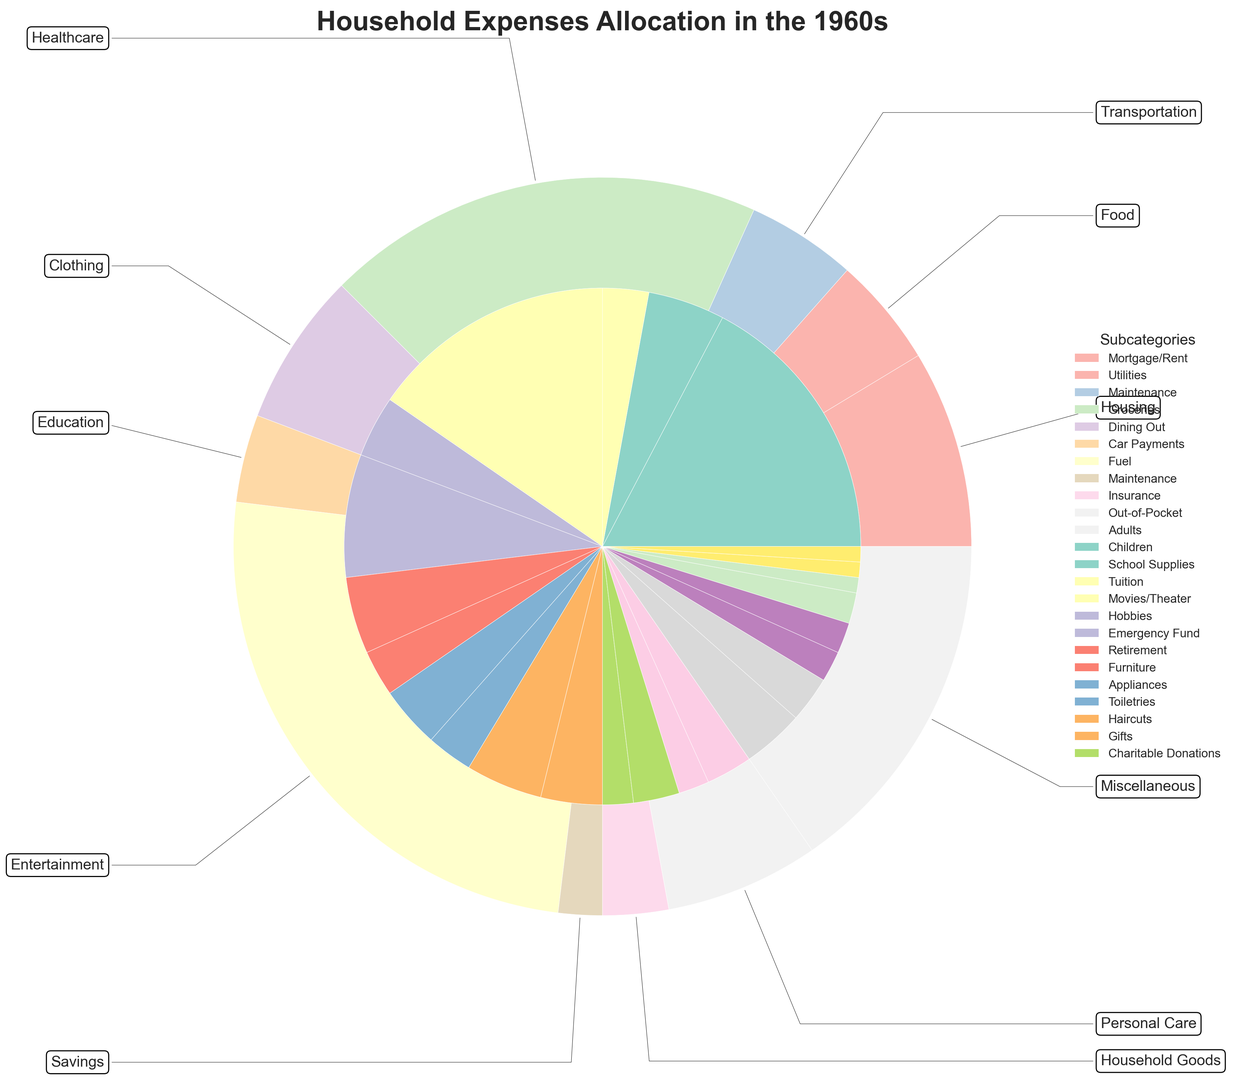What is the category with the highest proportion of expenses? According to the chart, Housing appears to have the largest segment, indicated by its significant portion of the outer pie chart as compared to other categories.
Answer: Housing How much more is spent on Housing compared to Transportation? Housing has 26% of the total expenses (18% Mortgage/Rent, 5% Utilities, 3% Maintenance), and Transportation has 16% of the total expenses (8% Car Payments, 5% Fuel, 3% Maintenance). The difference is 26% - 16% = 10%.
Answer: 10% Which subcategory has the highest percentage within the Food category? Within the Food category, the subcategories are Groceries (16%) and Dining Out (4%). Groceries has the higher percentage.
Answer: Groceries How does the percentage spent on Healthcare compare to the percentage spent on Entertainment? Healthcare stands at 7% (4% Insurance, 3% Out-of-Pocket) whereas Entertainment stands at 5% (2% Movies/Theater, 3% Hobbies). Healthcare spending is higher by 2%.
Answer: Healthcare is higher by 2% What is the combined percentage of expenses on Personal Care and Miscellaneous? Personal Care comprises 3% (2% Toiletries, 1% Haircuts) and Miscellaneous also totals 2% (1% Gifts, 1% Charitable Donations). Combined, it's 3% + 2% = 5%.
Answer: 5% Which category has a smaller percentage of expenses, Clothing or Savings? Clothing has 9% (5% Adults, 4% Children) while Savings has 7% (4% Emergency Fund, 3% Retirement). Savings has a smaller percentage.
Answer: Savings What percentage of the total household expenses is spent on categories other than Housing and Food? Expenses on categories other than Housing (26%) and Food (20%) can be calculated by subtracting their combined total from 100%. So, it's 100% - 26% - 20% = 54%.
Answer: 54% Is the percentage spent on Utilities higher or lower than on School Supplies? The percentage spent on Utilities is 5% while on School Supplies it's 2%. Utilities spending is higher.
Answer: Higher How do the combined expenses for Education compare to the combined expenses for Savings? Education sums up to 5% (2% School Supplies, 3% Tuition) and Savings also sums up to 7% (4% Emergency Fund, 3% Retirement). Thus, Education expenses are smaller.
Answer: Education is smaller What is the total percentage spent on Furniture and Appliances within Household Goods? Furniture takes up 2% and Appliances take up 2%. Together, they are 2% + 2% = 4%.
Answer: 4% 